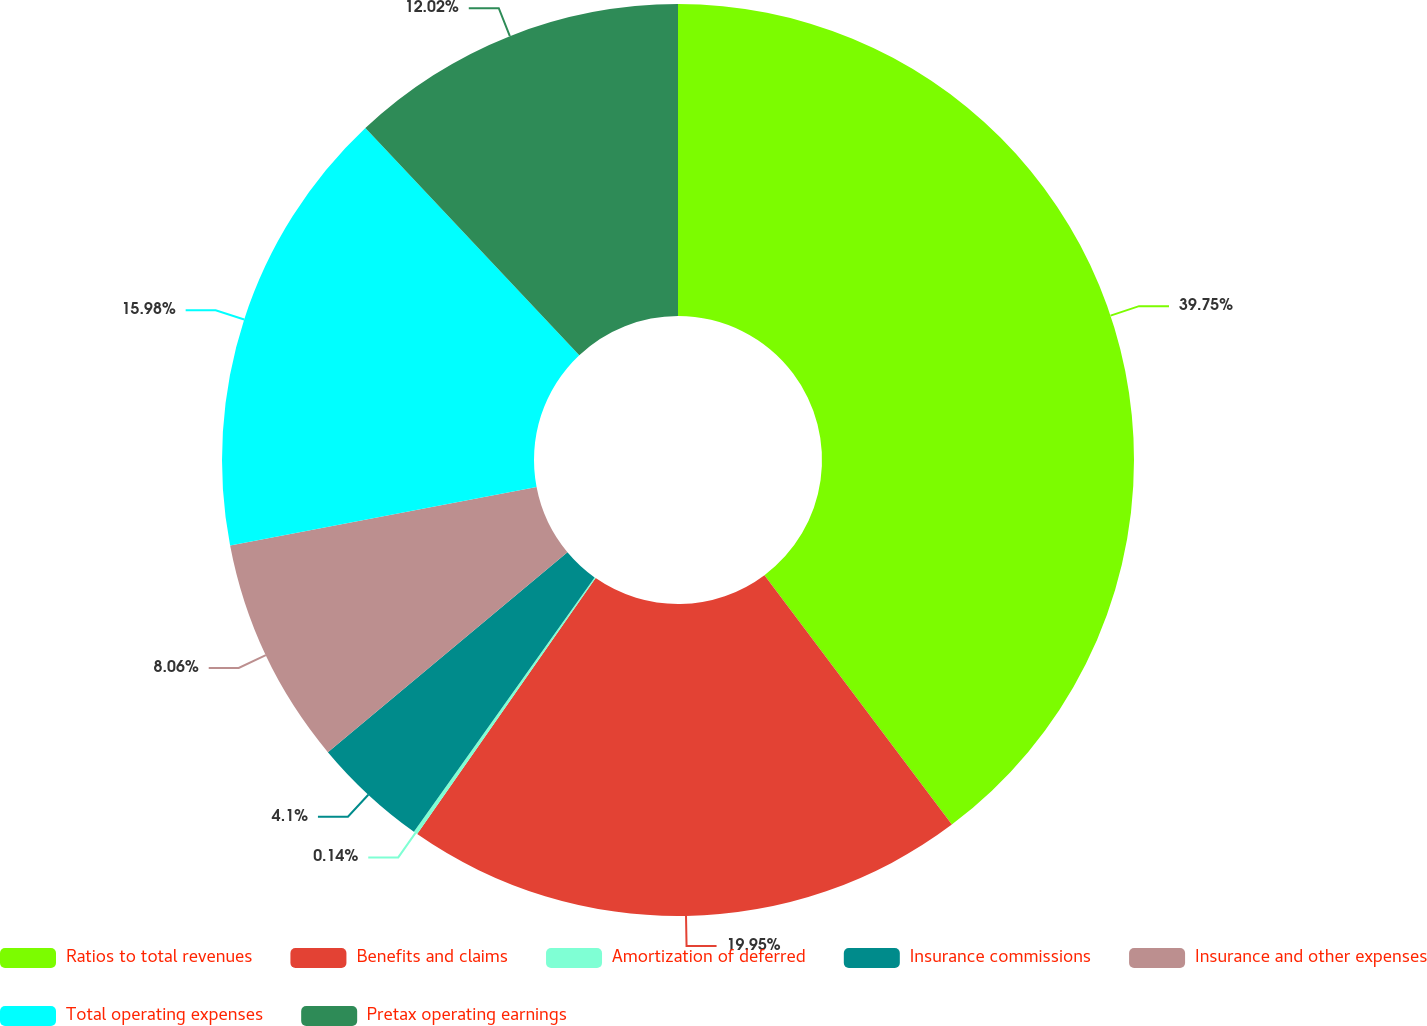<chart> <loc_0><loc_0><loc_500><loc_500><pie_chart><fcel>Ratios to total revenues<fcel>Benefits and claims<fcel>Amortization of deferred<fcel>Insurance commissions<fcel>Insurance and other expenses<fcel>Total operating expenses<fcel>Pretax operating earnings<nl><fcel>39.74%<fcel>19.94%<fcel>0.14%<fcel>4.1%<fcel>8.06%<fcel>15.98%<fcel>12.02%<nl></chart> 